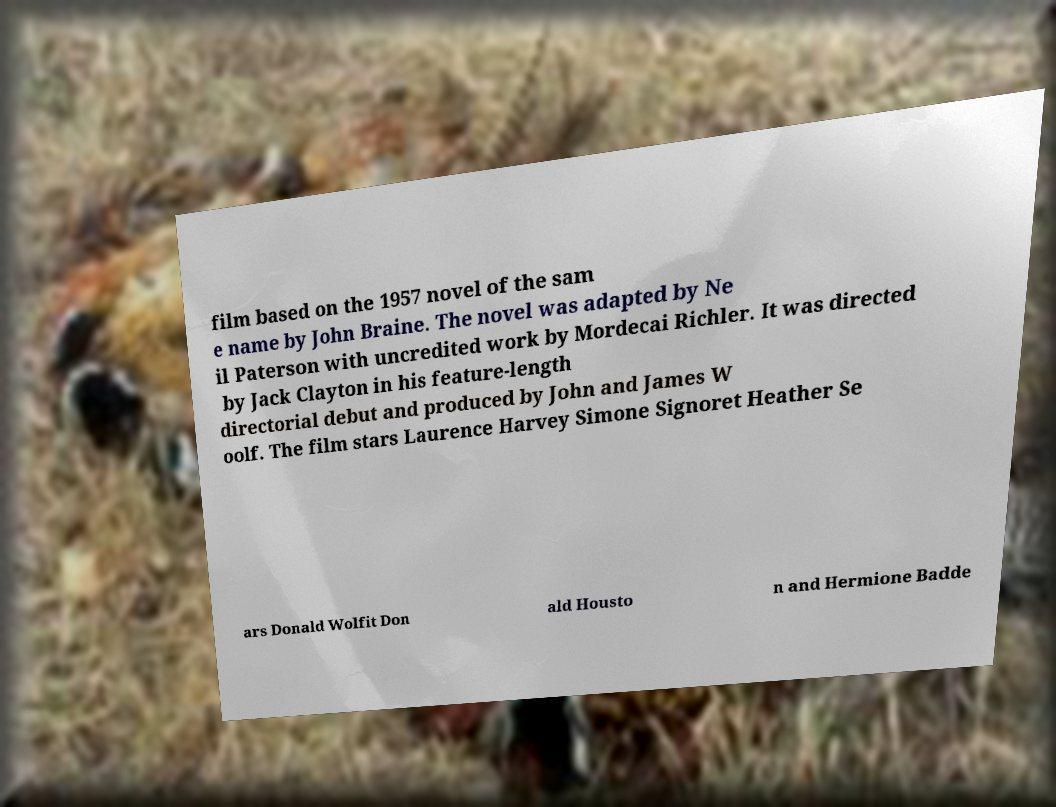Please read and relay the text visible in this image. What does it say? film based on the 1957 novel of the sam e name by John Braine. The novel was adapted by Ne il Paterson with uncredited work by Mordecai Richler. It was directed by Jack Clayton in his feature-length directorial debut and produced by John and James W oolf. The film stars Laurence Harvey Simone Signoret Heather Se ars Donald Wolfit Don ald Housto n and Hermione Badde 